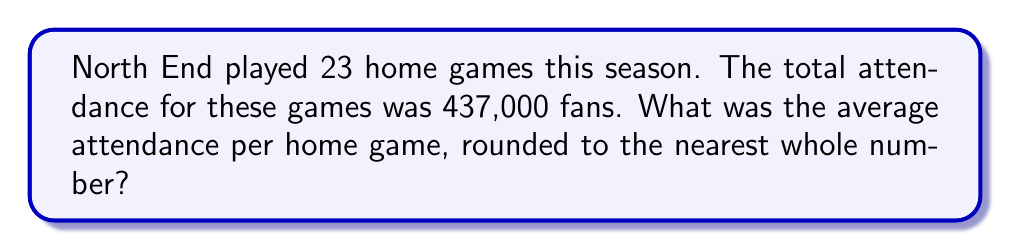Can you solve this math problem? To calculate the average attendance per home game, we need to divide the total attendance by the number of home games. Let's break this down step-by-step:

1. Given information:
   - Total number of home games: $n = 23$
   - Total attendance for all home games: $T = 437,000$ fans

2. The formula for calculating the average attendance $(A)$ is:

   $$A = \frac{T}{n}$$

3. Substituting the values:

   $$A = \frac{437,000}{23}$$

4. Performing the division:

   $$A = 19,000.8695652173913$$

5. Rounding to the nearest whole number:

   $$A \approx 19,001$$

Therefore, the average attendance per home game, rounded to the nearest whole number, is 19,001 fans.
Answer: 19,001 fans 